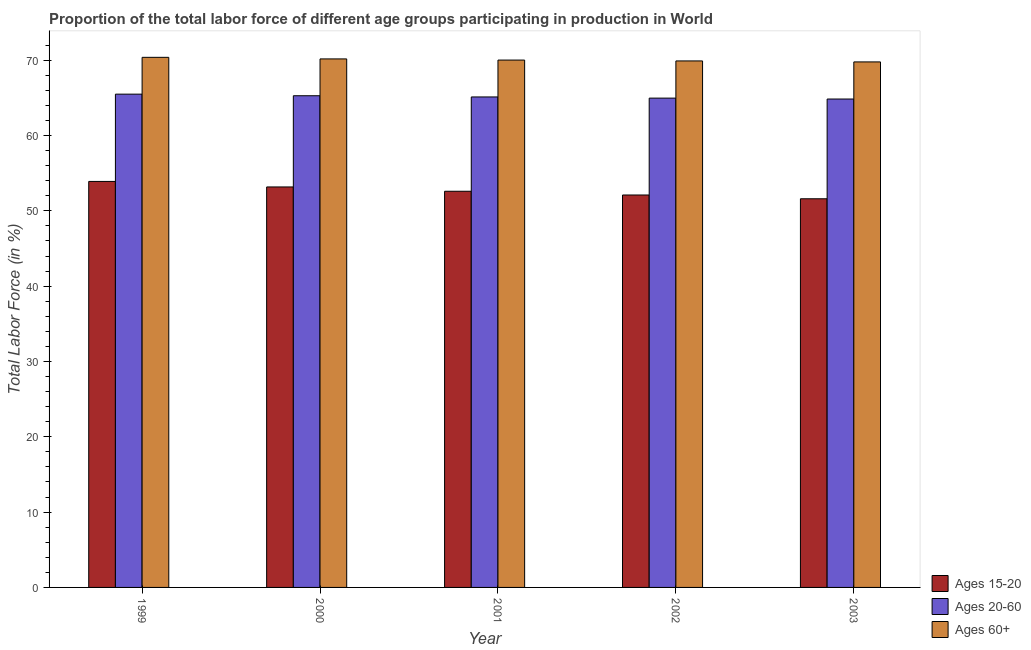How many different coloured bars are there?
Your answer should be very brief. 3. How many groups of bars are there?
Provide a short and direct response. 5. Are the number of bars per tick equal to the number of legend labels?
Ensure brevity in your answer.  Yes. How many bars are there on the 2nd tick from the right?
Offer a terse response. 3. What is the label of the 5th group of bars from the left?
Give a very brief answer. 2003. In how many cases, is the number of bars for a given year not equal to the number of legend labels?
Keep it short and to the point. 0. What is the percentage of labor force within the age group 15-20 in 1999?
Your answer should be very brief. 53.91. Across all years, what is the maximum percentage of labor force within the age group 15-20?
Offer a very short reply. 53.91. Across all years, what is the minimum percentage of labor force within the age group 15-20?
Your answer should be compact. 51.61. In which year was the percentage of labor force above age 60 maximum?
Your answer should be compact. 1999. In which year was the percentage of labor force within the age group 15-20 minimum?
Keep it short and to the point. 2003. What is the total percentage of labor force within the age group 15-20 in the graph?
Make the answer very short. 263.4. What is the difference between the percentage of labor force within the age group 20-60 in 1999 and that in 2000?
Offer a very short reply. 0.21. What is the difference between the percentage of labor force within the age group 15-20 in 2000 and the percentage of labor force within the age group 20-60 in 2003?
Your answer should be very brief. 1.57. What is the average percentage of labor force above age 60 per year?
Give a very brief answer. 70.05. In the year 2002, what is the difference between the percentage of labor force above age 60 and percentage of labor force within the age group 15-20?
Keep it short and to the point. 0. What is the ratio of the percentage of labor force within the age group 20-60 in 2001 to that in 2003?
Ensure brevity in your answer.  1. Is the difference between the percentage of labor force above age 60 in 1999 and 2003 greater than the difference between the percentage of labor force within the age group 20-60 in 1999 and 2003?
Your answer should be very brief. No. What is the difference between the highest and the second highest percentage of labor force within the age group 20-60?
Make the answer very short. 0.21. What is the difference between the highest and the lowest percentage of labor force above age 60?
Offer a terse response. 0.61. In how many years, is the percentage of labor force within the age group 15-20 greater than the average percentage of labor force within the age group 15-20 taken over all years?
Your answer should be compact. 2. What does the 1st bar from the left in 1999 represents?
Make the answer very short. Ages 15-20. What does the 2nd bar from the right in 2003 represents?
Provide a succinct answer. Ages 20-60. How many bars are there?
Your answer should be compact. 15. Are all the bars in the graph horizontal?
Make the answer very short. No. What is the difference between two consecutive major ticks on the Y-axis?
Your answer should be very brief. 10. Does the graph contain any zero values?
Provide a succinct answer. No. Does the graph contain grids?
Give a very brief answer. No. How many legend labels are there?
Your answer should be very brief. 3. How are the legend labels stacked?
Your response must be concise. Vertical. What is the title of the graph?
Keep it short and to the point. Proportion of the total labor force of different age groups participating in production in World. What is the label or title of the X-axis?
Give a very brief answer. Year. What is the label or title of the Y-axis?
Give a very brief answer. Total Labor Force (in %). What is the Total Labor Force (in %) of Ages 15-20 in 1999?
Offer a terse response. 53.91. What is the Total Labor Force (in %) of Ages 20-60 in 1999?
Provide a short and direct response. 65.5. What is the Total Labor Force (in %) of Ages 60+ in 1999?
Your answer should be compact. 70.39. What is the Total Labor Force (in %) in Ages 15-20 in 2000?
Make the answer very short. 53.18. What is the Total Labor Force (in %) of Ages 20-60 in 2000?
Your answer should be compact. 65.29. What is the Total Labor Force (in %) in Ages 60+ in 2000?
Your answer should be compact. 70.18. What is the Total Labor Force (in %) in Ages 15-20 in 2001?
Your answer should be compact. 52.6. What is the Total Labor Force (in %) of Ages 20-60 in 2001?
Provide a succinct answer. 65.13. What is the Total Labor Force (in %) in Ages 60+ in 2001?
Provide a short and direct response. 70.02. What is the Total Labor Force (in %) in Ages 15-20 in 2002?
Keep it short and to the point. 52.11. What is the Total Labor Force (in %) in Ages 20-60 in 2002?
Offer a terse response. 64.97. What is the Total Labor Force (in %) in Ages 60+ in 2002?
Give a very brief answer. 69.91. What is the Total Labor Force (in %) in Ages 15-20 in 2003?
Provide a short and direct response. 51.61. What is the Total Labor Force (in %) in Ages 20-60 in 2003?
Provide a short and direct response. 64.85. What is the Total Labor Force (in %) of Ages 60+ in 2003?
Offer a terse response. 69.78. Across all years, what is the maximum Total Labor Force (in %) of Ages 15-20?
Make the answer very short. 53.91. Across all years, what is the maximum Total Labor Force (in %) in Ages 20-60?
Your response must be concise. 65.5. Across all years, what is the maximum Total Labor Force (in %) of Ages 60+?
Give a very brief answer. 70.39. Across all years, what is the minimum Total Labor Force (in %) in Ages 15-20?
Your answer should be compact. 51.61. Across all years, what is the minimum Total Labor Force (in %) in Ages 20-60?
Your answer should be very brief. 64.85. Across all years, what is the minimum Total Labor Force (in %) in Ages 60+?
Provide a succinct answer. 69.78. What is the total Total Labor Force (in %) of Ages 15-20 in the graph?
Offer a very short reply. 263.4. What is the total Total Labor Force (in %) in Ages 20-60 in the graph?
Make the answer very short. 325.74. What is the total Total Labor Force (in %) in Ages 60+ in the graph?
Offer a terse response. 350.27. What is the difference between the Total Labor Force (in %) in Ages 15-20 in 1999 and that in 2000?
Provide a short and direct response. 0.73. What is the difference between the Total Labor Force (in %) in Ages 20-60 in 1999 and that in 2000?
Provide a succinct answer. 0.21. What is the difference between the Total Labor Force (in %) in Ages 60+ in 1999 and that in 2000?
Make the answer very short. 0.21. What is the difference between the Total Labor Force (in %) of Ages 15-20 in 1999 and that in 2001?
Ensure brevity in your answer.  1.3. What is the difference between the Total Labor Force (in %) in Ages 20-60 in 1999 and that in 2001?
Give a very brief answer. 0.37. What is the difference between the Total Labor Force (in %) in Ages 60+ in 1999 and that in 2001?
Give a very brief answer. 0.36. What is the difference between the Total Labor Force (in %) in Ages 15-20 in 1999 and that in 2002?
Provide a short and direct response. 1.8. What is the difference between the Total Labor Force (in %) in Ages 20-60 in 1999 and that in 2002?
Provide a succinct answer. 0.53. What is the difference between the Total Labor Force (in %) in Ages 60+ in 1999 and that in 2002?
Give a very brief answer. 0.48. What is the difference between the Total Labor Force (in %) in Ages 15-20 in 1999 and that in 2003?
Provide a succinct answer. 2.3. What is the difference between the Total Labor Force (in %) of Ages 20-60 in 1999 and that in 2003?
Your answer should be very brief. 0.65. What is the difference between the Total Labor Force (in %) of Ages 60+ in 1999 and that in 2003?
Provide a short and direct response. 0.61. What is the difference between the Total Labor Force (in %) of Ages 15-20 in 2000 and that in 2001?
Your response must be concise. 0.57. What is the difference between the Total Labor Force (in %) of Ages 20-60 in 2000 and that in 2001?
Offer a terse response. 0.16. What is the difference between the Total Labor Force (in %) in Ages 60+ in 2000 and that in 2001?
Your response must be concise. 0.15. What is the difference between the Total Labor Force (in %) of Ages 15-20 in 2000 and that in 2002?
Offer a very short reply. 1.07. What is the difference between the Total Labor Force (in %) in Ages 20-60 in 2000 and that in 2002?
Keep it short and to the point. 0.32. What is the difference between the Total Labor Force (in %) of Ages 60+ in 2000 and that in 2002?
Keep it short and to the point. 0.27. What is the difference between the Total Labor Force (in %) in Ages 15-20 in 2000 and that in 2003?
Give a very brief answer. 1.57. What is the difference between the Total Labor Force (in %) of Ages 20-60 in 2000 and that in 2003?
Keep it short and to the point. 0.44. What is the difference between the Total Labor Force (in %) in Ages 60+ in 2000 and that in 2003?
Give a very brief answer. 0.4. What is the difference between the Total Labor Force (in %) in Ages 15-20 in 2001 and that in 2002?
Your answer should be very brief. 0.5. What is the difference between the Total Labor Force (in %) in Ages 20-60 in 2001 and that in 2002?
Your answer should be very brief. 0.15. What is the difference between the Total Labor Force (in %) of Ages 60+ in 2001 and that in 2002?
Your answer should be very brief. 0.12. What is the difference between the Total Labor Force (in %) of Ages 20-60 in 2001 and that in 2003?
Offer a terse response. 0.28. What is the difference between the Total Labor Force (in %) of Ages 60+ in 2001 and that in 2003?
Provide a short and direct response. 0.24. What is the difference between the Total Labor Force (in %) of Ages 15-20 in 2002 and that in 2003?
Your answer should be very brief. 0.5. What is the difference between the Total Labor Force (in %) in Ages 20-60 in 2002 and that in 2003?
Your response must be concise. 0.12. What is the difference between the Total Labor Force (in %) of Ages 60+ in 2002 and that in 2003?
Your answer should be very brief. 0.13. What is the difference between the Total Labor Force (in %) of Ages 15-20 in 1999 and the Total Labor Force (in %) of Ages 20-60 in 2000?
Give a very brief answer. -11.38. What is the difference between the Total Labor Force (in %) in Ages 15-20 in 1999 and the Total Labor Force (in %) in Ages 60+ in 2000?
Your answer should be compact. -16.27. What is the difference between the Total Labor Force (in %) in Ages 20-60 in 1999 and the Total Labor Force (in %) in Ages 60+ in 2000?
Give a very brief answer. -4.68. What is the difference between the Total Labor Force (in %) in Ages 15-20 in 1999 and the Total Labor Force (in %) in Ages 20-60 in 2001?
Make the answer very short. -11.22. What is the difference between the Total Labor Force (in %) in Ages 15-20 in 1999 and the Total Labor Force (in %) in Ages 60+ in 2001?
Your response must be concise. -16.12. What is the difference between the Total Labor Force (in %) in Ages 20-60 in 1999 and the Total Labor Force (in %) in Ages 60+ in 2001?
Your response must be concise. -4.53. What is the difference between the Total Labor Force (in %) of Ages 15-20 in 1999 and the Total Labor Force (in %) of Ages 20-60 in 2002?
Your response must be concise. -11.06. What is the difference between the Total Labor Force (in %) of Ages 15-20 in 1999 and the Total Labor Force (in %) of Ages 60+ in 2002?
Keep it short and to the point. -16. What is the difference between the Total Labor Force (in %) in Ages 20-60 in 1999 and the Total Labor Force (in %) in Ages 60+ in 2002?
Your response must be concise. -4.41. What is the difference between the Total Labor Force (in %) of Ages 15-20 in 1999 and the Total Labor Force (in %) of Ages 20-60 in 2003?
Provide a short and direct response. -10.94. What is the difference between the Total Labor Force (in %) in Ages 15-20 in 1999 and the Total Labor Force (in %) in Ages 60+ in 2003?
Your response must be concise. -15.87. What is the difference between the Total Labor Force (in %) of Ages 20-60 in 1999 and the Total Labor Force (in %) of Ages 60+ in 2003?
Offer a very short reply. -4.28. What is the difference between the Total Labor Force (in %) in Ages 15-20 in 2000 and the Total Labor Force (in %) in Ages 20-60 in 2001?
Your response must be concise. -11.95. What is the difference between the Total Labor Force (in %) of Ages 15-20 in 2000 and the Total Labor Force (in %) of Ages 60+ in 2001?
Provide a short and direct response. -16.85. What is the difference between the Total Labor Force (in %) of Ages 20-60 in 2000 and the Total Labor Force (in %) of Ages 60+ in 2001?
Offer a terse response. -4.74. What is the difference between the Total Labor Force (in %) of Ages 15-20 in 2000 and the Total Labor Force (in %) of Ages 20-60 in 2002?
Your answer should be compact. -11.8. What is the difference between the Total Labor Force (in %) in Ages 15-20 in 2000 and the Total Labor Force (in %) in Ages 60+ in 2002?
Make the answer very short. -16.73. What is the difference between the Total Labor Force (in %) of Ages 20-60 in 2000 and the Total Labor Force (in %) of Ages 60+ in 2002?
Your response must be concise. -4.62. What is the difference between the Total Labor Force (in %) in Ages 15-20 in 2000 and the Total Labor Force (in %) in Ages 20-60 in 2003?
Your answer should be compact. -11.67. What is the difference between the Total Labor Force (in %) of Ages 15-20 in 2000 and the Total Labor Force (in %) of Ages 60+ in 2003?
Make the answer very short. -16.6. What is the difference between the Total Labor Force (in %) in Ages 20-60 in 2000 and the Total Labor Force (in %) in Ages 60+ in 2003?
Offer a very short reply. -4.49. What is the difference between the Total Labor Force (in %) in Ages 15-20 in 2001 and the Total Labor Force (in %) in Ages 20-60 in 2002?
Provide a succinct answer. -12.37. What is the difference between the Total Labor Force (in %) in Ages 15-20 in 2001 and the Total Labor Force (in %) in Ages 60+ in 2002?
Your answer should be very brief. -17.3. What is the difference between the Total Labor Force (in %) in Ages 20-60 in 2001 and the Total Labor Force (in %) in Ages 60+ in 2002?
Your response must be concise. -4.78. What is the difference between the Total Labor Force (in %) in Ages 15-20 in 2001 and the Total Labor Force (in %) in Ages 20-60 in 2003?
Ensure brevity in your answer.  -12.25. What is the difference between the Total Labor Force (in %) of Ages 15-20 in 2001 and the Total Labor Force (in %) of Ages 60+ in 2003?
Your response must be concise. -17.17. What is the difference between the Total Labor Force (in %) in Ages 20-60 in 2001 and the Total Labor Force (in %) in Ages 60+ in 2003?
Your response must be concise. -4.65. What is the difference between the Total Labor Force (in %) in Ages 15-20 in 2002 and the Total Labor Force (in %) in Ages 20-60 in 2003?
Offer a very short reply. -12.74. What is the difference between the Total Labor Force (in %) in Ages 15-20 in 2002 and the Total Labor Force (in %) in Ages 60+ in 2003?
Your answer should be very brief. -17.67. What is the difference between the Total Labor Force (in %) of Ages 20-60 in 2002 and the Total Labor Force (in %) of Ages 60+ in 2003?
Your response must be concise. -4.81. What is the average Total Labor Force (in %) of Ages 15-20 per year?
Give a very brief answer. 52.68. What is the average Total Labor Force (in %) of Ages 20-60 per year?
Keep it short and to the point. 65.15. What is the average Total Labor Force (in %) of Ages 60+ per year?
Give a very brief answer. 70.06. In the year 1999, what is the difference between the Total Labor Force (in %) in Ages 15-20 and Total Labor Force (in %) in Ages 20-60?
Offer a very short reply. -11.59. In the year 1999, what is the difference between the Total Labor Force (in %) in Ages 15-20 and Total Labor Force (in %) in Ages 60+?
Your answer should be very brief. -16.48. In the year 1999, what is the difference between the Total Labor Force (in %) in Ages 20-60 and Total Labor Force (in %) in Ages 60+?
Give a very brief answer. -4.89. In the year 2000, what is the difference between the Total Labor Force (in %) of Ages 15-20 and Total Labor Force (in %) of Ages 20-60?
Provide a short and direct response. -12.11. In the year 2000, what is the difference between the Total Labor Force (in %) in Ages 15-20 and Total Labor Force (in %) in Ages 60+?
Keep it short and to the point. -17. In the year 2000, what is the difference between the Total Labor Force (in %) in Ages 20-60 and Total Labor Force (in %) in Ages 60+?
Provide a short and direct response. -4.89. In the year 2001, what is the difference between the Total Labor Force (in %) of Ages 15-20 and Total Labor Force (in %) of Ages 20-60?
Your answer should be very brief. -12.52. In the year 2001, what is the difference between the Total Labor Force (in %) of Ages 15-20 and Total Labor Force (in %) of Ages 60+?
Your answer should be very brief. -17.42. In the year 2001, what is the difference between the Total Labor Force (in %) in Ages 20-60 and Total Labor Force (in %) in Ages 60+?
Make the answer very short. -4.9. In the year 2002, what is the difference between the Total Labor Force (in %) in Ages 15-20 and Total Labor Force (in %) in Ages 20-60?
Offer a very short reply. -12.86. In the year 2002, what is the difference between the Total Labor Force (in %) in Ages 15-20 and Total Labor Force (in %) in Ages 60+?
Give a very brief answer. -17.8. In the year 2002, what is the difference between the Total Labor Force (in %) of Ages 20-60 and Total Labor Force (in %) of Ages 60+?
Provide a succinct answer. -4.94. In the year 2003, what is the difference between the Total Labor Force (in %) of Ages 15-20 and Total Labor Force (in %) of Ages 20-60?
Offer a terse response. -13.24. In the year 2003, what is the difference between the Total Labor Force (in %) of Ages 15-20 and Total Labor Force (in %) of Ages 60+?
Provide a short and direct response. -18.17. In the year 2003, what is the difference between the Total Labor Force (in %) in Ages 20-60 and Total Labor Force (in %) in Ages 60+?
Make the answer very short. -4.93. What is the ratio of the Total Labor Force (in %) in Ages 15-20 in 1999 to that in 2000?
Your answer should be very brief. 1.01. What is the ratio of the Total Labor Force (in %) of Ages 20-60 in 1999 to that in 2000?
Your answer should be compact. 1. What is the ratio of the Total Labor Force (in %) of Ages 60+ in 1999 to that in 2000?
Provide a succinct answer. 1. What is the ratio of the Total Labor Force (in %) of Ages 15-20 in 1999 to that in 2001?
Ensure brevity in your answer.  1.02. What is the ratio of the Total Labor Force (in %) in Ages 20-60 in 1999 to that in 2001?
Your response must be concise. 1.01. What is the ratio of the Total Labor Force (in %) of Ages 60+ in 1999 to that in 2001?
Your response must be concise. 1.01. What is the ratio of the Total Labor Force (in %) of Ages 15-20 in 1999 to that in 2002?
Ensure brevity in your answer.  1.03. What is the ratio of the Total Labor Force (in %) in Ages 60+ in 1999 to that in 2002?
Keep it short and to the point. 1.01. What is the ratio of the Total Labor Force (in %) in Ages 15-20 in 1999 to that in 2003?
Provide a succinct answer. 1.04. What is the ratio of the Total Labor Force (in %) of Ages 20-60 in 1999 to that in 2003?
Your answer should be very brief. 1.01. What is the ratio of the Total Labor Force (in %) of Ages 60+ in 1999 to that in 2003?
Keep it short and to the point. 1.01. What is the ratio of the Total Labor Force (in %) of Ages 15-20 in 2000 to that in 2001?
Provide a short and direct response. 1.01. What is the ratio of the Total Labor Force (in %) of Ages 15-20 in 2000 to that in 2002?
Provide a short and direct response. 1.02. What is the ratio of the Total Labor Force (in %) in Ages 20-60 in 2000 to that in 2002?
Your answer should be compact. 1. What is the ratio of the Total Labor Force (in %) of Ages 15-20 in 2000 to that in 2003?
Offer a terse response. 1.03. What is the ratio of the Total Labor Force (in %) of Ages 60+ in 2000 to that in 2003?
Ensure brevity in your answer.  1.01. What is the ratio of the Total Labor Force (in %) in Ages 15-20 in 2001 to that in 2002?
Provide a succinct answer. 1.01. What is the ratio of the Total Labor Force (in %) of Ages 20-60 in 2001 to that in 2002?
Provide a succinct answer. 1. What is the ratio of the Total Labor Force (in %) in Ages 15-20 in 2001 to that in 2003?
Provide a succinct answer. 1.02. What is the ratio of the Total Labor Force (in %) of Ages 20-60 in 2001 to that in 2003?
Your answer should be compact. 1. What is the ratio of the Total Labor Force (in %) of Ages 60+ in 2001 to that in 2003?
Offer a very short reply. 1. What is the ratio of the Total Labor Force (in %) in Ages 15-20 in 2002 to that in 2003?
Provide a succinct answer. 1.01. What is the ratio of the Total Labor Force (in %) in Ages 20-60 in 2002 to that in 2003?
Make the answer very short. 1. What is the difference between the highest and the second highest Total Labor Force (in %) of Ages 15-20?
Your response must be concise. 0.73. What is the difference between the highest and the second highest Total Labor Force (in %) in Ages 20-60?
Keep it short and to the point. 0.21. What is the difference between the highest and the second highest Total Labor Force (in %) in Ages 60+?
Give a very brief answer. 0.21. What is the difference between the highest and the lowest Total Labor Force (in %) in Ages 15-20?
Offer a terse response. 2.3. What is the difference between the highest and the lowest Total Labor Force (in %) of Ages 20-60?
Offer a very short reply. 0.65. What is the difference between the highest and the lowest Total Labor Force (in %) in Ages 60+?
Your answer should be compact. 0.61. 